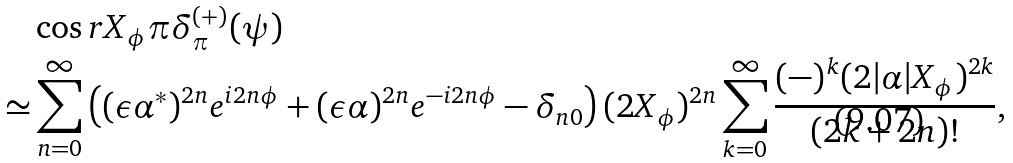<formula> <loc_0><loc_0><loc_500><loc_500>& \cos r X _ { \phi } \pi \delta _ { \pi } ^ { ( + ) } ( \psi ) \\ \simeq & \sum _ { n = 0 } ^ { \infty } \left ( ( \epsilon \alpha ^ { * } ) ^ { 2 n } e ^ { i 2 n \phi } + ( \epsilon \alpha ) ^ { 2 n } e ^ { - i 2 n \phi } - \delta _ { n 0 } \right ) ( 2 X _ { \phi } ) ^ { 2 n } \sum _ { k = 0 } ^ { \infty } \frac { ( - ) ^ { k } ( 2 | \alpha | X _ { \phi } ) ^ { 2 k } } { ( 2 k + 2 n ) ! } ,</formula> 